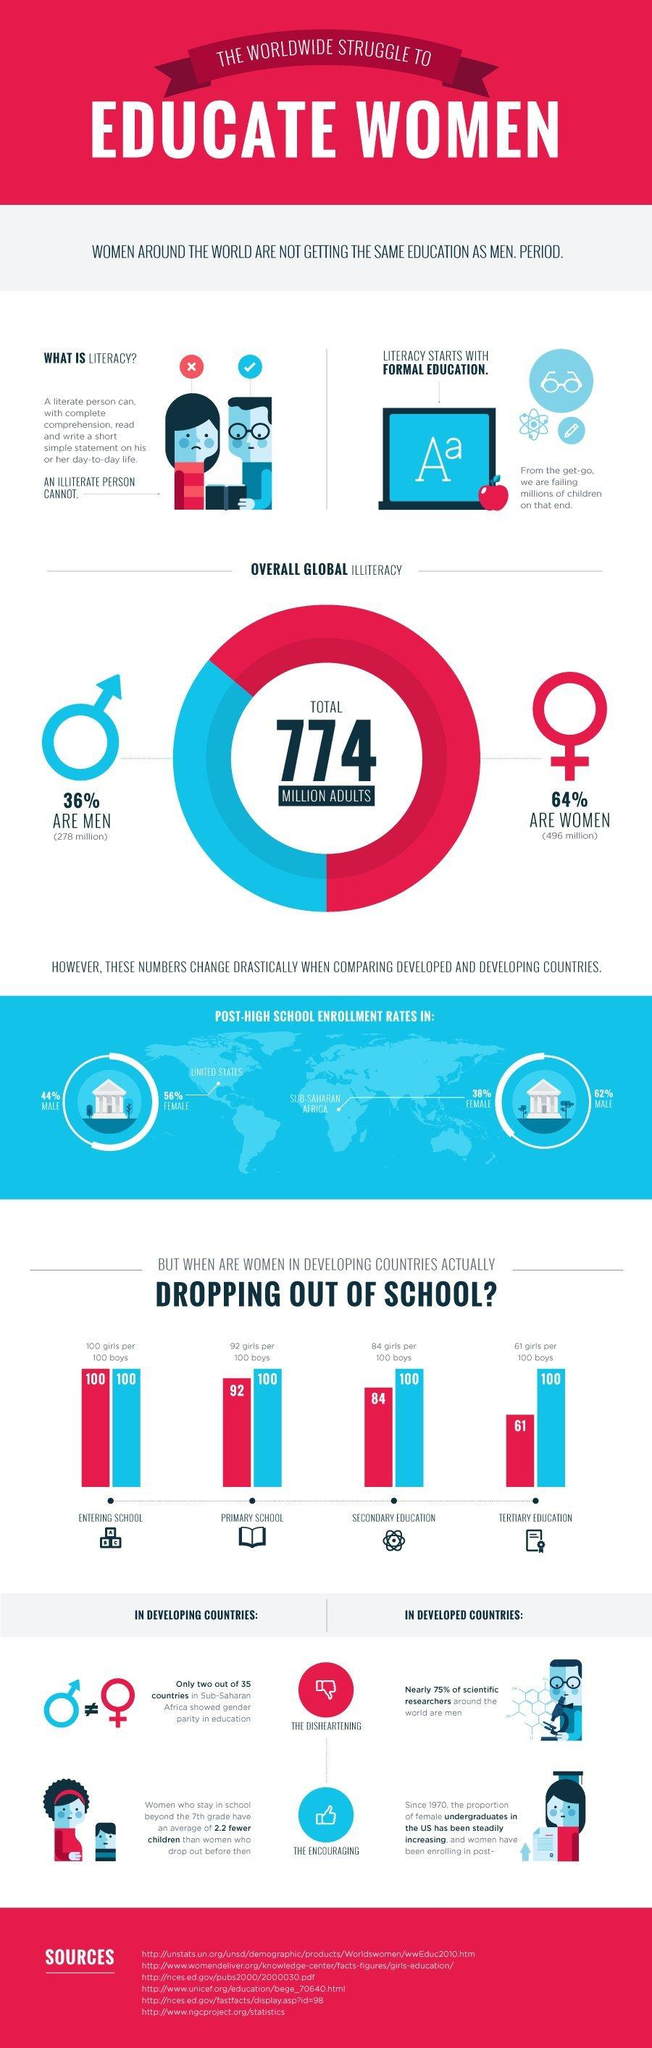Mention a couple of crucial points in this snapshot. The post-high school enrollment rates among males in the United States and Sub-Saharan Africa are significantly different, with males in the United States having a higher enrollment rate of 18%. The post-high school enrollment rate of females in the U.S. and Sub-Saharan Africa is significantly different, with females in the U.S. enrolling at a rate of 18%. In secondary education, there are 16 girls who drop out for every 100 girls. 64% of men are literate. According to recent statistics, approximately 39 out of every 100 girls in tertiary education have dropped out. 